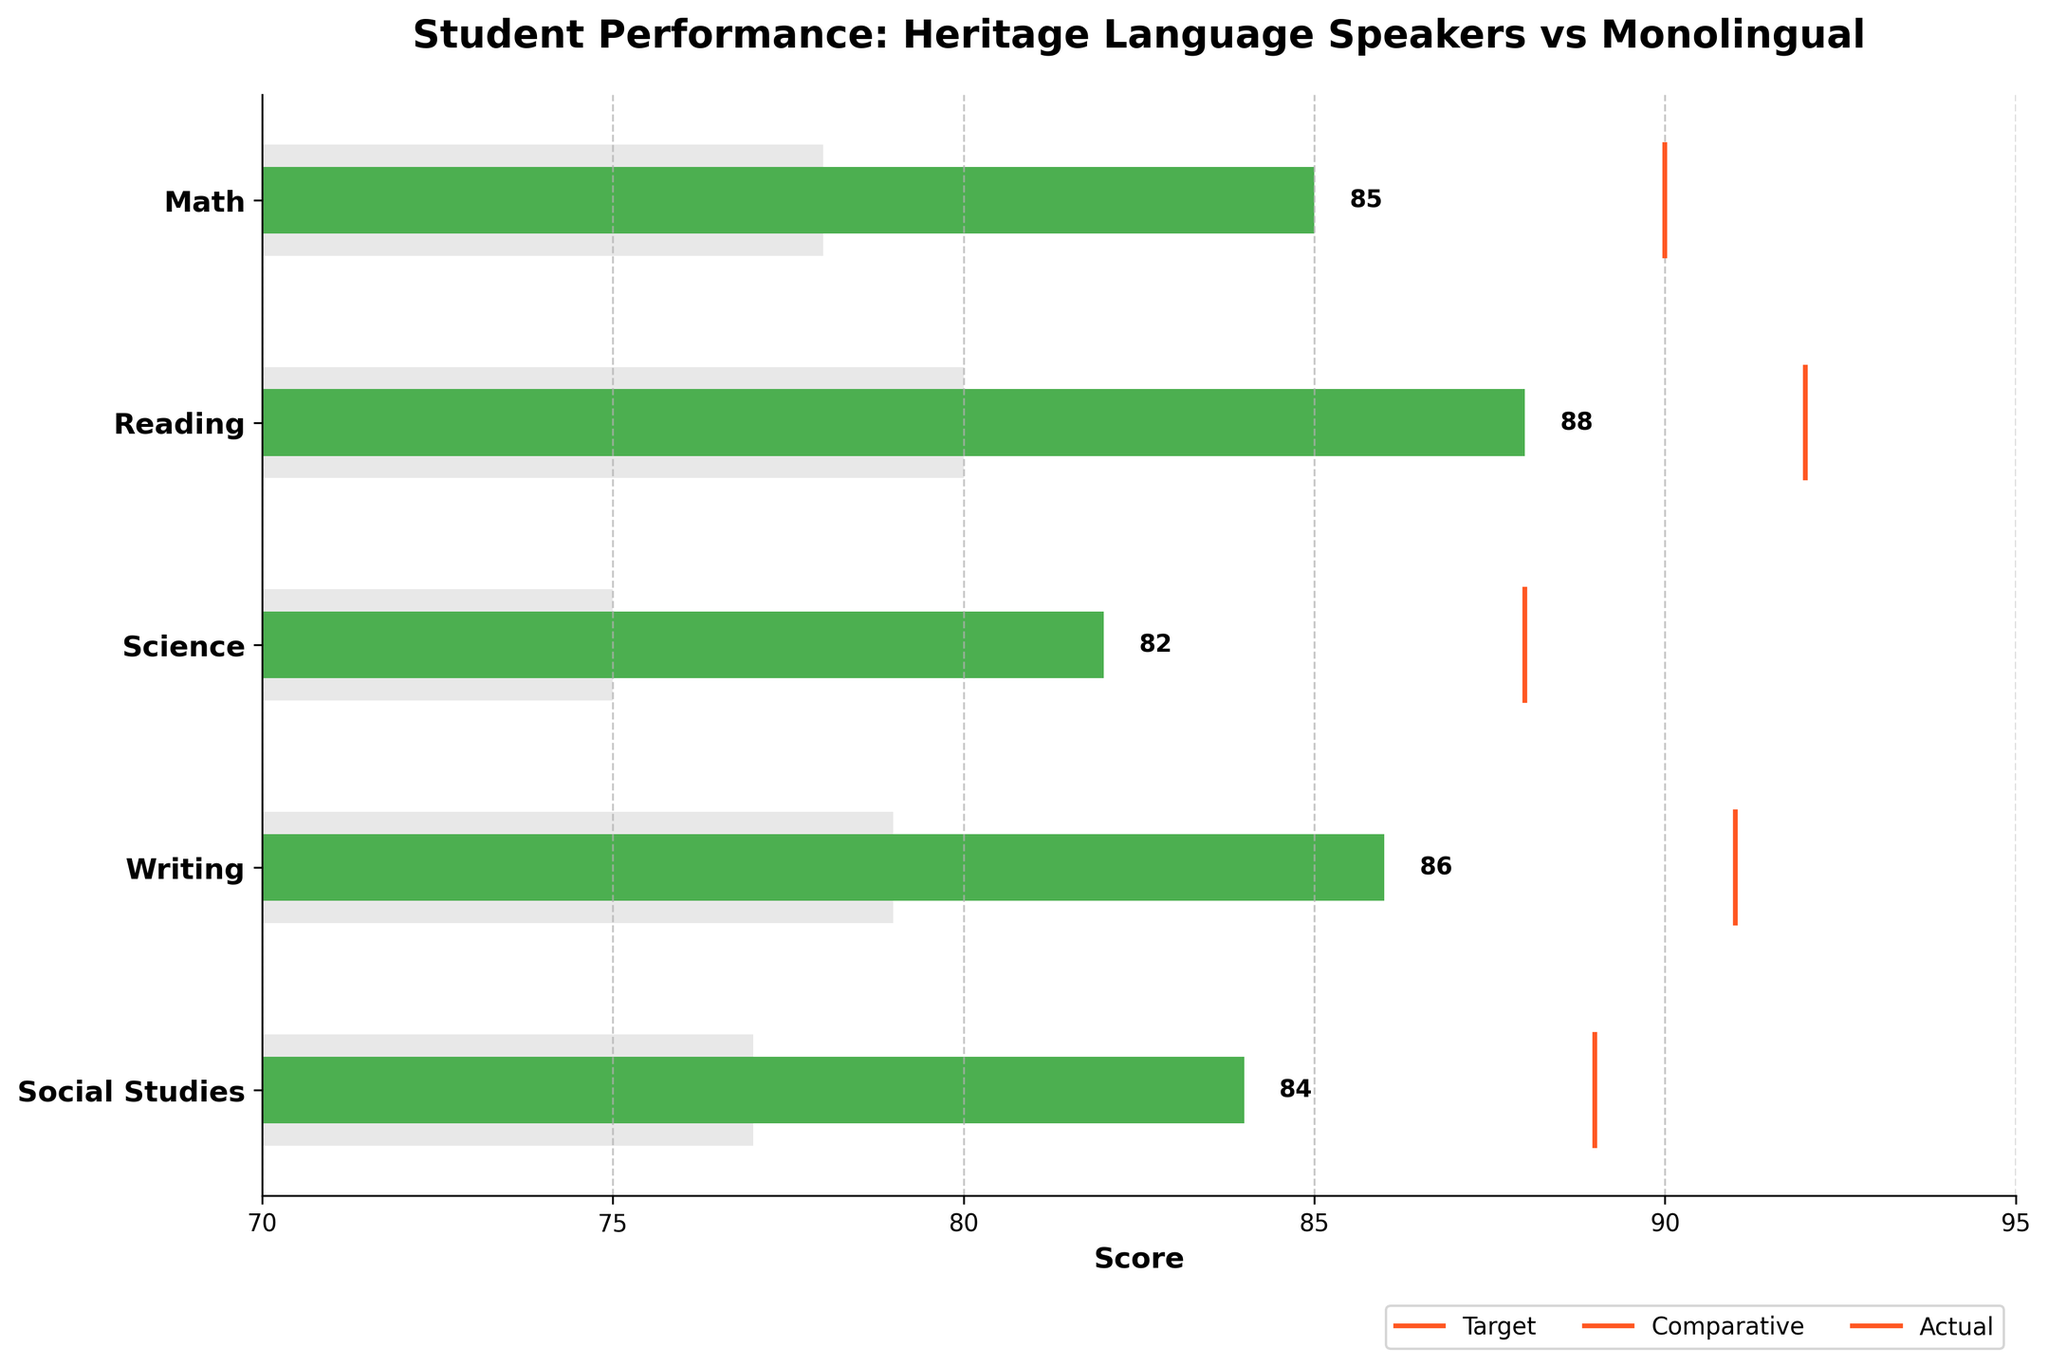What's the title of the figure? The title of the figure is located at the top and summarizes the main theme of the chart. Here it reads "Student Performance: Heritage Language Speakers vs Monolingual".
Answer: Student Performance: Heritage Language Speakers vs Monolingual What is the actual score for Reading? Find the Reading category on the y-axis and look at the length of the dark green bar in relation to the x-axis. The end of this bar aligns with the value 88.
Answer: 88 How do the actual scores for Reading and Writing compare to each other? Find both the Reading and Writing categories on the y-axis. The length of the green bar for Reading is 88 while for Writing, it is 86.
Answer: Reading is 2 points higher than Writing Which subject has the largest gap between the comparative and actual scores? For each subject, check the difference between the endpoints of the light grey bar (comparative) and the dark green bar (actual). Math has a comparative score of 78 and an actual score of 85, making the gap 7, which is the largest among all subjects.
Answer: Math What is the target score for Science and by how many points does it exceed the actual score? Locate the Science category and identify the vertical orange line, which is the target score at 88. The actual green bar ends at 82. Subtract the actual from the target (88 - 82 = 6).
Answer: 88, 6 points Which subject has the closest actual score to its target score? Compare the difference between the actual score (green bar) and target score (orange line) for each subject. Reading has an actual score of 88 and a target score of 92, making the difference 4 points, which is the closest.
Answer: Reading On average, how much lower are the actual scores from their targets? Calculate the difference between actual and target scores for each subject (Math: 5, Reading: 4, Science: 6, Writing: 5, Social Studies: 5). Sum these differences (5+4+6+5+5 = 25) and divide by the number of subjects (25/5 = 5).
Answer: 5 points lower Which subject's comparative score is closest to 80? Compare the comparative scores (light grey bars) to the value 80. Reading has a comparative score that exactly matches 80.
Answer: Reading How many subjects have an actual score that is higher than their comparative score? Count the number of categories where the dark green bar (actual score) is longer than the light grey bar (comparative score). All categories (Math, Reading, Science, Writing, Social Studies) meet this criterion.
Answer: 5 subjects 